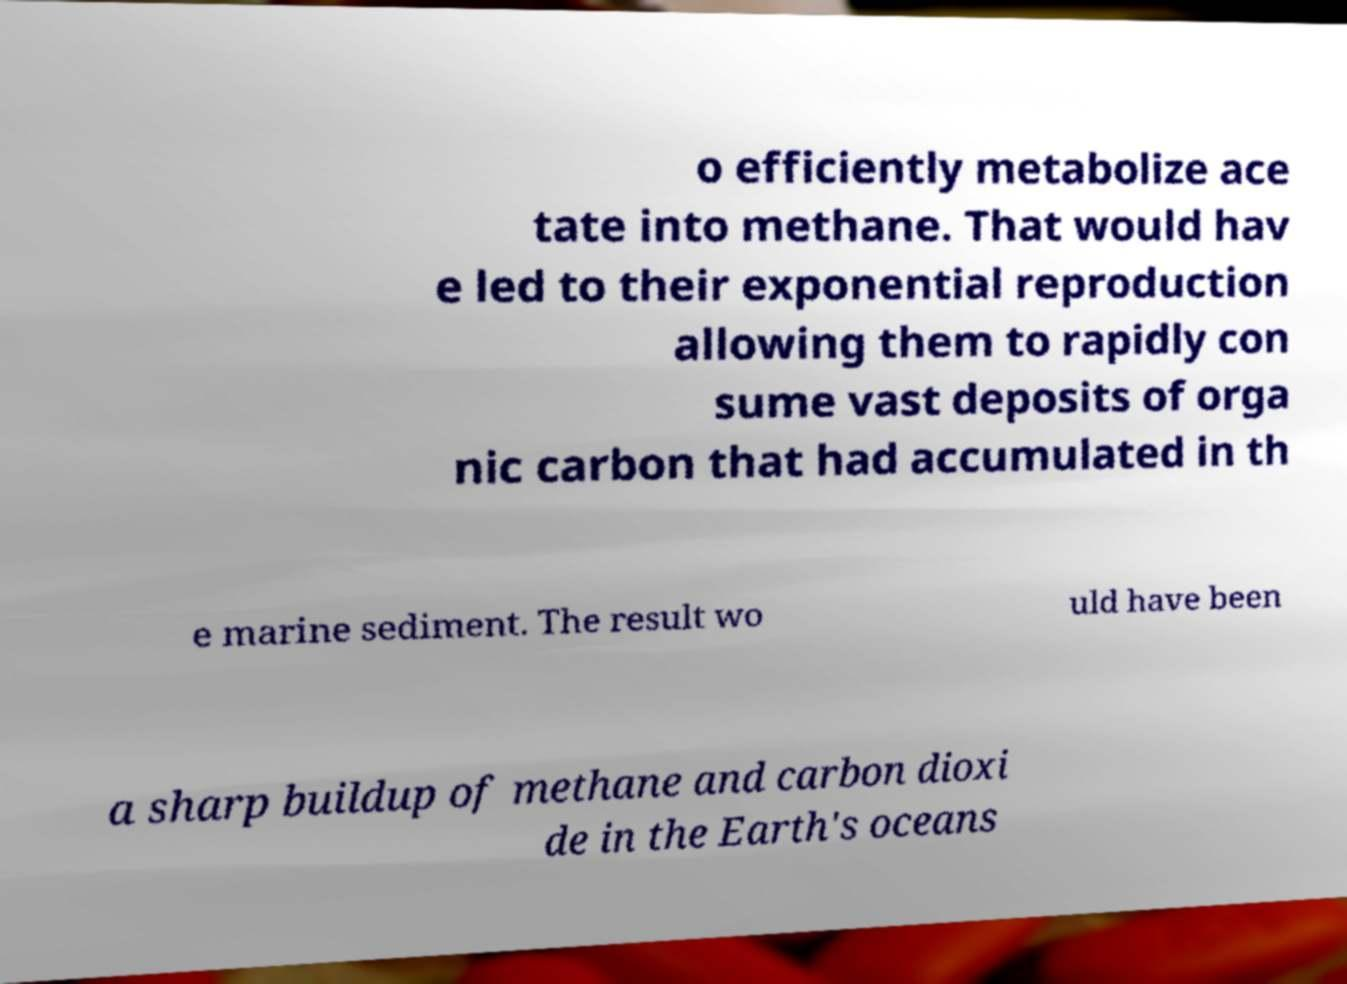Please read and relay the text visible in this image. What does it say? o efficiently metabolize ace tate into methane. That would hav e led to their exponential reproduction allowing them to rapidly con sume vast deposits of orga nic carbon that had accumulated in th e marine sediment. The result wo uld have been a sharp buildup of methane and carbon dioxi de in the Earth's oceans 